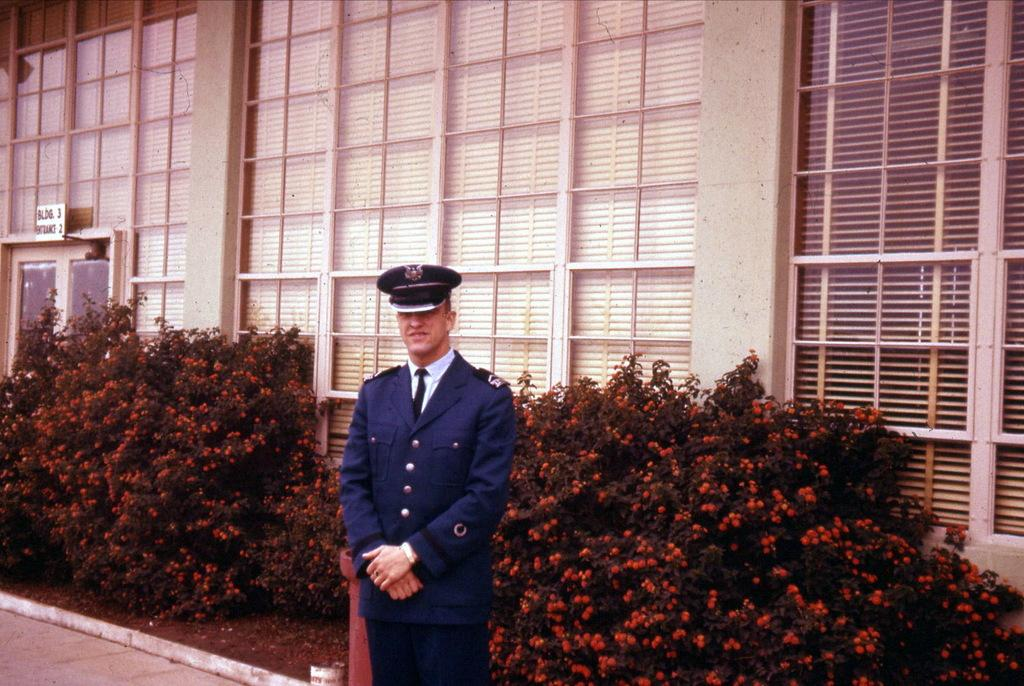What is the main subject of the image? There is a person standing at the bottom of the image. What is the person wearing on their head? The person is wearing a cap. What can be seen in the background of the image? There are plants in the background of the image. What is located at the top of the image? There is a building at the top of the image. What type of fear can be seen on the person's face in the image? There is no indication of fear on the person's face in the image. What type of industry is depicted in the image? The image does not depict any industry; it features a person, plants, and a building. 